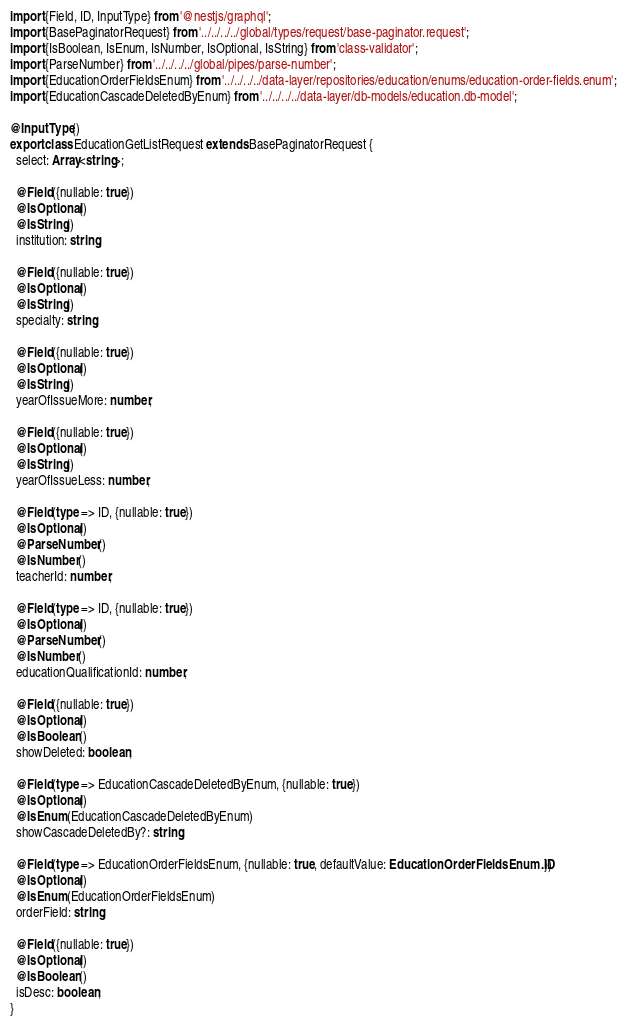<code> <loc_0><loc_0><loc_500><loc_500><_TypeScript_>import {Field, ID, InputType} from '@nestjs/graphql';
import {BasePaginatorRequest} from '../../../../global/types/request/base-paginator.request';
import {IsBoolean, IsEnum, IsNumber, IsOptional, IsString} from 'class-validator';
import {ParseNumber} from '../../../../global/pipes/parse-number';
import {EducationOrderFieldsEnum} from '../../../../data-layer/repositories/education/enums/education-order-fields.enum';
import {EducationCascadeDeletedByEnum} from '../../../../data-layer/db-models/education.db-model';

@InputType()
export class EducationGetListRequest extends BasePaginatorRequest {
  select: Array<string>;

  @Field({nullable: true})
  @IsOptional()
  @IsString()
  institution: string;

  @Field({nullable: true})
  @IsOptional()
  @IsString()
  specialty: string;

  @Field({nullable: true})
  @IsOptional()
  @IsString()
  yearOfIssueMore: number;

  @Field({nullable: true})
  @IsOptional()
  @IsString()
  yearOfIssueLess: number;

  @Field(type => ID, {nullable: true})
  @IsOptional()
  @ParseNumber()
  @IsNumber()
  teacherId: number;

  @Field(type => ID, {nullable: true})
  @IsOptional()
  @ParseNumber()
  @IsNumber()
  educationQualificationId: number;

  @Field({nullable: true})
  @IsOptional()
  @IsBoolean()
  showDeleted: boolean;

  @Field(type => EducationCascadeDeletedByEnum, {nullable: true})
  @IsOptional()
  @IsEnum(EducationCascadeDeletedByEnum)
  showCascadeDeletedBy?: string;

  @Field(type => EducationOrderFieldsEnum, {nullable: true, defaultValue: EducationOrderFieldsEnum.ID})
  @IsOptional()
  @IsEnum(EducationOrderFieldsEnum)
  orderField: string;

  @Field({nullable: true})
  @IsOptional()
  @IsBoolean()
  isDesc: boolean;
}
</code> 